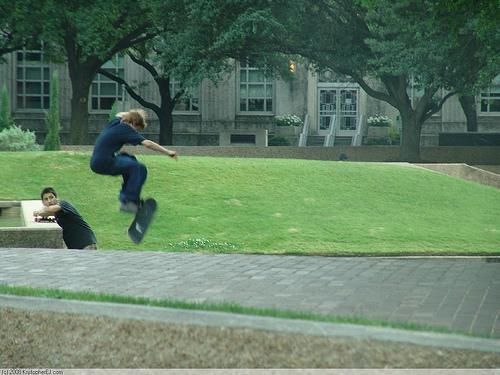How many people are in the photo?
Give a very brief answer. 2. 